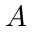<formula> <loc_0><loc_0><loc_500><loc_500>A</formula> 